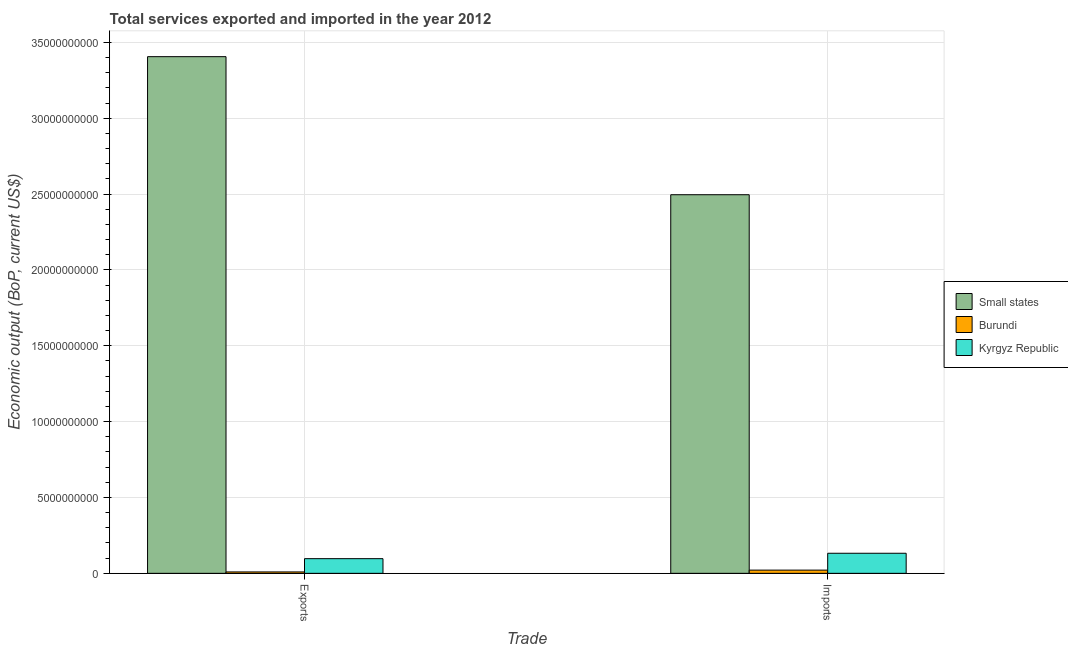How many different coloured bars are there?
Keep it short and to the point. 3. Are the number of bars per tick equal to the number of legend labels?
Ensure brevity in your answer.  Yes. How many bars are there on the 1st tick from the left?
Ensure brevity in your answer.  3. How many bars are there on the 2nd tick from the right?
Make the answer very short. 3. What is the label of the 2nd group of bars from the left?
Make the answer very short. Imports. What is the amount of service imports in Kyrgyz Republic?
Provide a succinct answer. 1.32e+09. Across all countries, what is the maximum amount of service exports?
Offer a terse response. 3.41e+1. Across all countries, what is the minimum amount of service imports?
Your answer should be very brief. 2.12e+08. In which country was the amount of service imports maximum?
Offer a terse response. Small states. In which country was the amount of service exports minimum?
Your response must be concise. Burundi. What is the total amount of service imports in the graph?
Offer a terse response. 2.65e+1. What is the difference between the amount of service exports in Burundi and that in Small states?
Provide a succinct answer. -3.40e+1. What is the difference between the amount of service imports in Burundi and the amount of service exports in Kyrgyz Republic?
Provide a short and direct response. -7.55e+08. What is the average amount of service exports per country?
Your answer should be compact. 1.17e+1. What is the difference between the amount of service exports and amount of service imports in Burundi?
Offer a terse response. -1.19e+08. In how many countries, is the amount of service exports greater than 14000000000 US$?
Your answer should be very brief. 1. What is the ratio of the amount of service exports in Burundi to that in Small states?
Offer a very short reply. 0. Is the amount of service imports in Small states less than that in Burundi?
Your answer should be very brief. No. In how many countries, is the amount of service exports greater than the average amount of service exports taken over all countries?
Make the answer very short. 1. What does the 3rd bar from the left in Imports represents?
Offer a very short reply. Kyrgyz Republic. What does the 2nd bar from the right in Exports represents?
Make the answer very short. Burundi. How many countries are there in the graph?
Provide a succinct answer. 3. What is the difference between two consecutive major ticks on the Y-axis?
Make the answer very short. 5.00e+09. Where does the legend appear in the graph?
Your response must be concise. Center right. How many legend labels are there?
Your response must be concise. 3. How are the legend labels stacked?
Make the answer very short. Vertical. What is the title of the graph?
Provide a succinct answer. Total services exported and imported in the year 2012. Does "Maldives" appear as one of the legend labels in the graph?
Give a very brief answer. No. What is the label or title of the X-axis?
Make the answer very short. Trade. What is the label or title of the Y-axis?
Offer a terse response. Economic output (BoP, current US$). What is the Economic output (BoP, current US$) of Small states in Exports?
Your answer should be very brief. 3.41e+1. What is the Economic output (BoP, current US$) of Burundi in Exports?
Provide a short and direct response. 9.28e+07. What is the Economic output (BoP, current US$) in Kyrgyz Republic in Exports?
Your response must be concise. 9.67e+08. What is the Economic output (BoP, current US$) in Small states in Imports?
Your answer should be very brief. 2.50e+1. What is the Economic output (BoP, current US$) in Burundi in Imports?
Your answer should be compact. 2.12e+08. What is the Economic output (BoP, current US$) of Kyrgyz Republic in Imports?
Your answer should be very brief. 1.32e+09. Across all Trade, what is the maximum Economic output (BoP, current US$) of Small states?
Your answer should be very brief. 3.41e+1. Across all Trade, what is the maximum Economic output (BoP, current US$) of Burundi?
Ensure brevity in your answer.  2.12e+08. Across all Trade, what is the maximum Economic output (BoP, current US$) in Kyrgyz Republic?
Provide a succinct answer. 1.32e+09. Across all Trade, what is the minimum Economic output (BoP, current US$) of Small states?
Make the answer very short. 2.50e+1. Across all Trade, what is the minimum Economic output (BoP, current US$) of Burundi?
Make the answer very short. 9.28e+07. Across all Trade, what is the minimum Economic output (BoP, current US$) of Kyrgyz Republic?
Ensure brevity in your answer.  9.67e+08. What is the total Economic output (BoP, current US$) in Small states in the graph?
Provide a short and direct response. 5.90e+1. What is the total Economic output (BoP, current US$) in Burundi in the graph?
Make the answer very short. 3.04e+08. What is the total Economic output (BoP, current US$) in Kyrgyz Republic in the graph?
Your answer should be compact. 2.29e+09. What is the difference between the Economic output (BoP, current US$) in Small states in Exports and that in Imports?
Your answer should be compact. 9.10e+09. What is the difference between the Economic output (BoP, current US$) in Burundi in Exports and that in Imports?
Your answer should be compact. -1.19e+08. What is the difference between the Economic output (BoP, current US$) in Kyrgyz Republic in Exports and that in Imports?
Make the answer very short. -3.57e+08. What is the difference between the Economic output (BoP, current US$) of Small states in Exports and the Economic output (BoP, current US$) of Burundi in Imports?
Make the answer very short. 3.39e+1. What is the difference between the Economic output (BoP, current US$) of Small states in Exports and the Economic output (BoP, current US$) of Kyrgyz Republic in Imports?
Give a very brief answer. 3.27e+1. What is the difference between the Economic output (BoP, current US$) of Burundi in Exports and the Economic output (BoP, current US$) of Kyrgyz Republic in Imports?
Offer a very short reply. -1.23e+09. What is the average Economic output (BoP, current US$) of Small states per Trade?
Make the answer very short. 2.95e+1. What is the average Economic output (BoP, current US$) of Burundi per Trade?
Your response must be concise. 1.52e+08. What is the average Economic output (BoP, current US$) of Kyrgyz Republic per Trade?
Provide a succinct answer. 1.14e+09. What is the difference between the Economic output (BoP, current US$) in Small states and Economic output (BoP, current US$) in Burundi in Exports?
Offer a terse response. 3.40e+1. What is the difference between the Economic output (BoP, current US$) in Small states and Economic output (BoP, current US$) in Kyrgyz Republic in Exports?
Make the answer very short. 3.31e+1. What is the difference between the Economic output (BoP, current US$) of Burundi and Economic output (BoP, current US$) of Kyrgyz Republic in Exports?
Keep it short and to the point. -8.74e+08. What is the difference between the Economic output (BoP, current US$) in Small states and Economic output (BoP, current US$) in Burundi in Imports?
Keep it short and to the point. 2.47e+1. What is the difference between the Economic output (BoP, current US$) in Small states and Economic output (BoP, current US$) in Kyrgyz Republic in Imports?
Your response must be concise. 2.36e+1. What is the difference between the Economic output (BoP, current US$) of Burundi and Economic output (BoP, current US$) of Kyrgyz Republic in Imports?
Give a very brief answer. -1.11e+09. What is the ratio of the Economic output (BoP, current US$) in Small states in Exports to that in Imports?
Provide a succinct answer. 1.36. What is the ratio of the Economic output (BoP, current US$) in Burundi in Exports to that in Imports?
Keep it short and to the point. 0.44. What is the ratio of the Economic output (BoP, current US$) of Kyrgyz Republic in Exports to that in Imports?
Provide a short and direct response. 0.73. What is the difference between the highest and the second highest Economic output (BoP, current US$) of Small states?
Keep it short and to the point. 9.10e+09. What is the difference between the highest and the second highest Economic output (BoP, current US$) in Burundi?
Provide a succinct answer. 1.19e+08. What is the difference between the highest and the second highest Economic output (BoP, current US$) in Kyrgyz Republic?
Keep it short and to the point. 3.57e+08. What is the difference between the highest and the lowest Economic output (BoP, current US$) of Small states?
Give a very brief answer. 9.10e+09. What is the difference between the highest and the lowest Economic output (BoP, current US$) in Burundi?
Offer a terse response. 1.19e+08. What is the difference between the highest and the lowest Economic output (BoP, current US$) in Kyrgyz Republic?
Provide a short and direct response. 3.57e+08. 